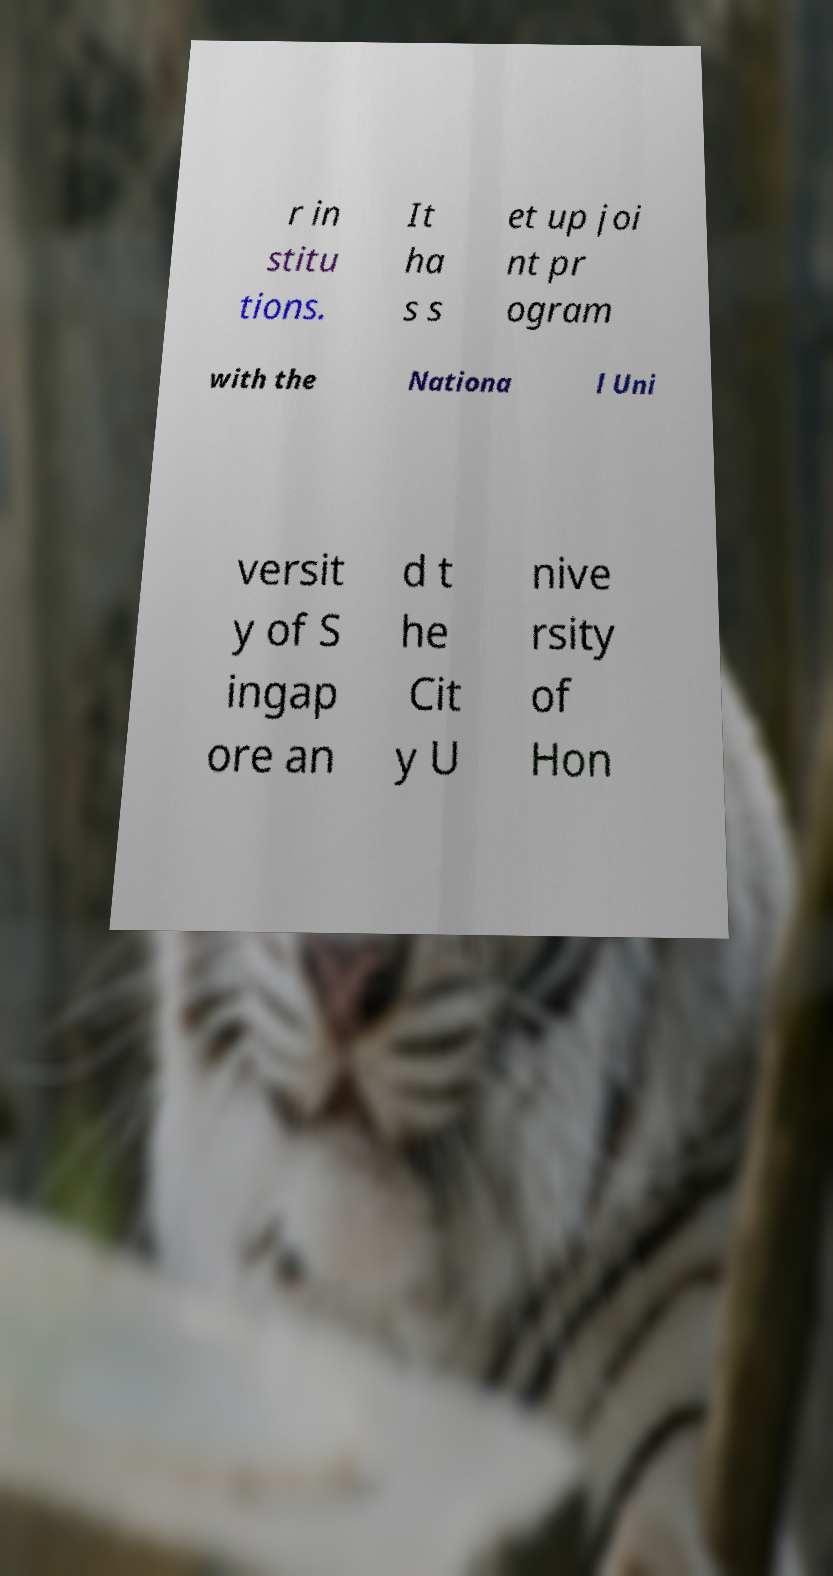Please identify and transcribe the text found in this image. r in stitu tions. It ha s s et up joi nt pr ogram with the Nationa l Uni versit y of S ingap ore an d t he Cit y U nive rsity of Hon 